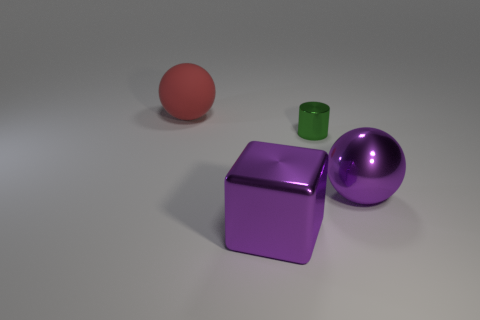There is a purple metal object to the left of the small metal object; is its shape the same as the shiny object behind the big purple ball?
Your answer should be compact. No. Is there any other thing that is the same shape as the green thing?
Your answer should be very brief. No. The large object that is made of the same material as the purple ball is what shape?
Provide a succinct answer. Cube. Are there the same number of rubber balls on the right side of the large purple metal ball and gray metallic things?
Make the answer very short. Yes. Is the material of the sphere to the right of the red sphere the same as the large object behind the small green object?
Keep it short and to the point. No. There is a small thing that is right of the object in front of the metallic sphere; what shape is it?
Your response must be concise. Cylinder. There is a big sphere that is made of the same material as the tiny thing; what color is it?
Your response must be concise. Purple. Does the metal sphere have the same color as the metal cube?
Your response must be concise. Yes. There is a matte thing that is the same size as the purple metallic block; what shape is it?
Provide a short and direct response. Sphere. How big is the metal sphere?
Offer a terse response. Large. 